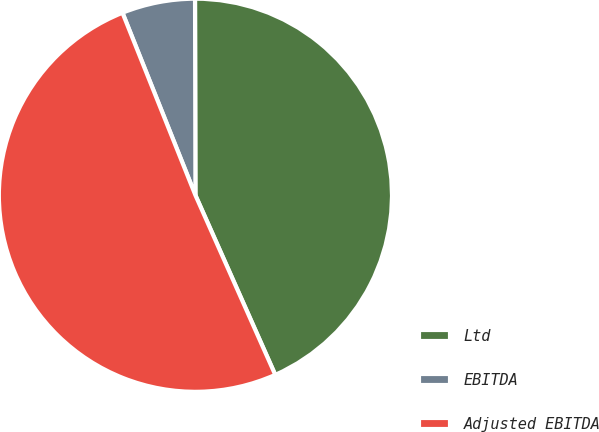<chart> <loc_0><loc_0><loc_500><loc_500><pie_chart><fcel>Ltd<fcel>EBITDA<fcel>Adjusted EBITDA<nl><fcel>43.37%<fcel>6.02%<fcel>50.6%<nl></chart> 